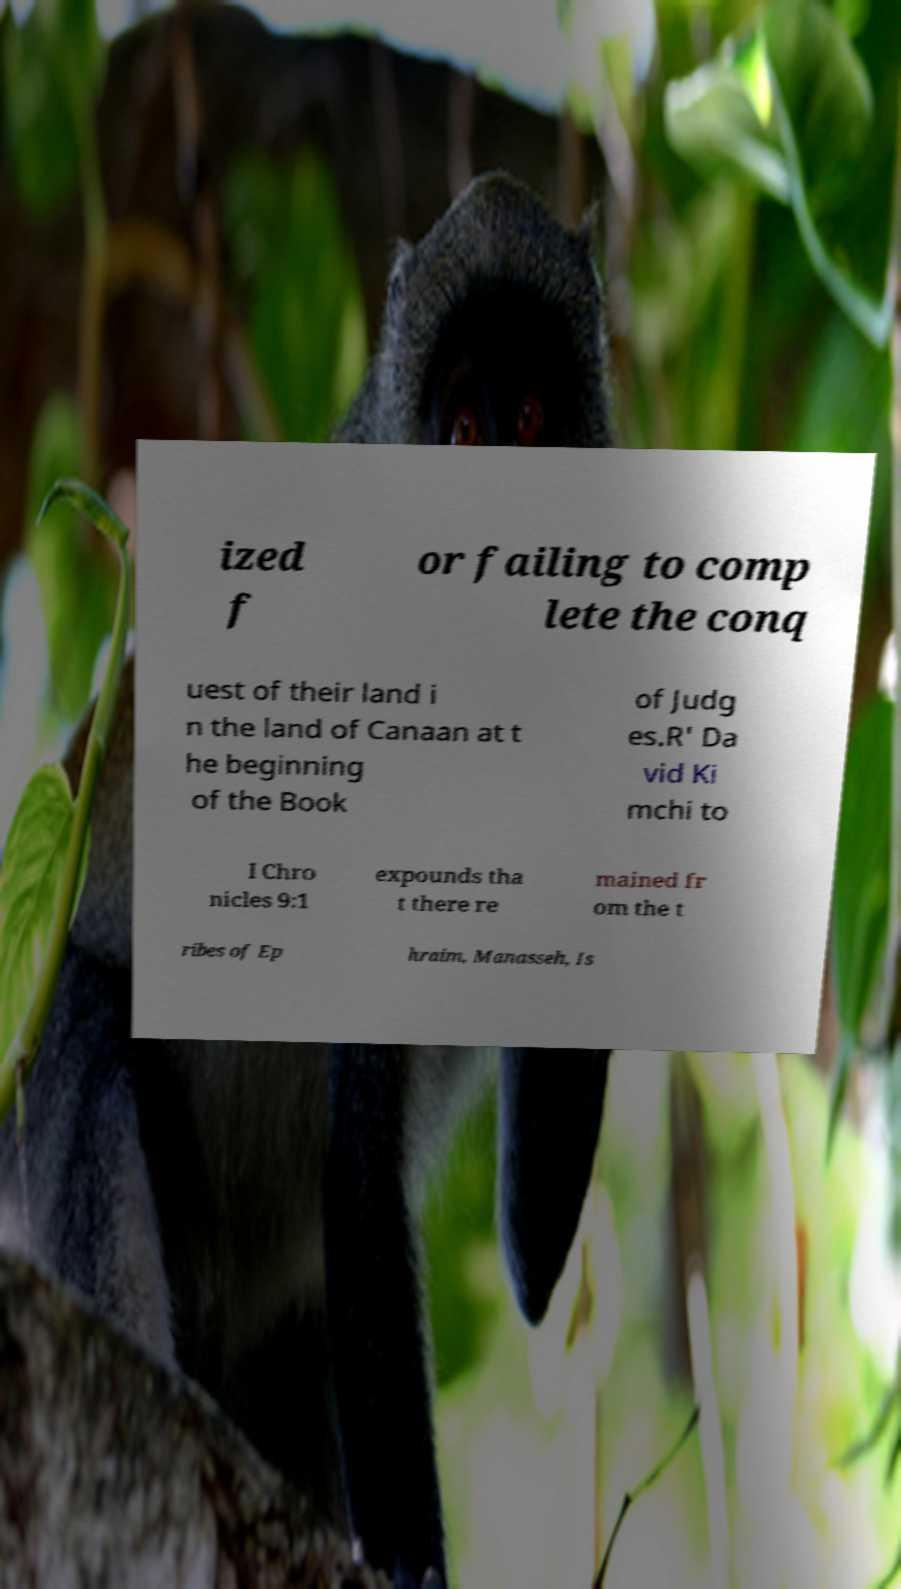Please read and relay the text visible in this image. What does it say? ized f or failing to comp lete the conq uest of their land i n the land of Canaan at t he beginning of the Book of Judg es.R' Da vid Ki mchi to I Chro nicles 9:1 expounds tha t there re mained fr om the t ribes of Ep hraim, Manasseh, Is 